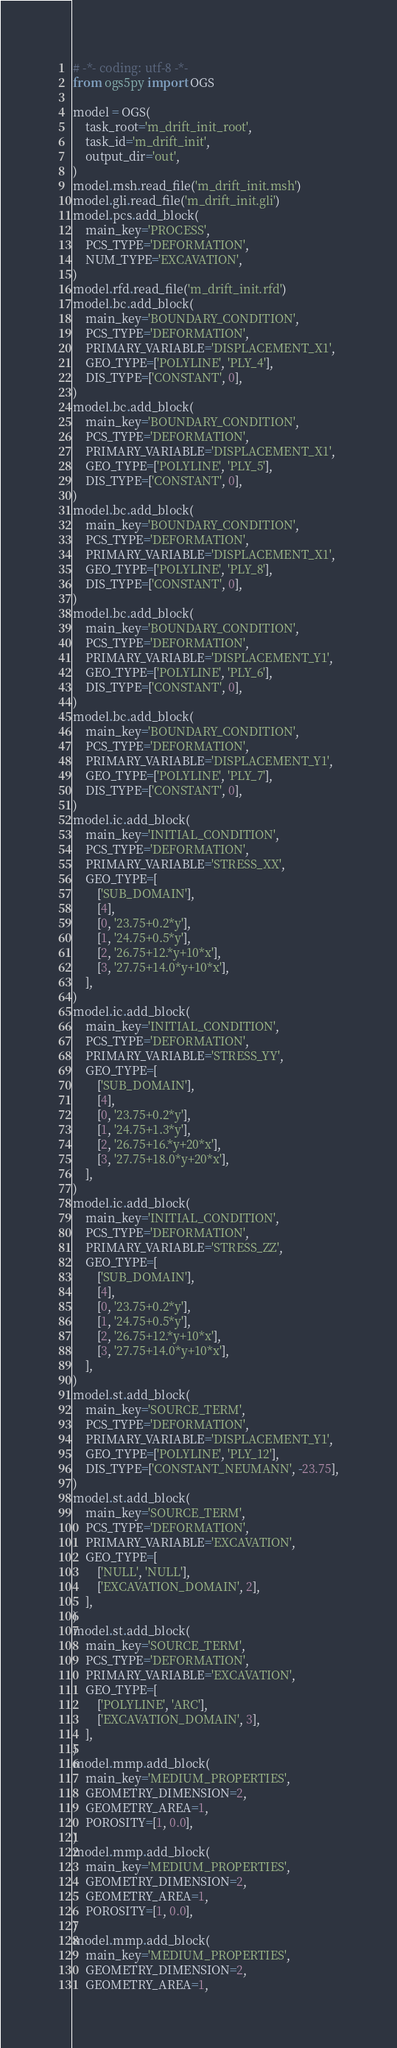<code> <loc_0><loc_0><loc_500><loc_500><_Python_># -*- coding: utf-8 -*-
from ogs5py import OGS

model = OGS(
    task_root='m_drift_init_root',
    task_id='m_drift_init',
    output_dir='out',
)
model.msh.read_file('m_drift_init.msh')
model.gli.read_file('m_drift_init.gli')
model.pcs.add_block(
    main_key='PROCESS',
    PCS_TYPE='DEFORMATION',
    NUM_TYPE='EXCAVATION',
)
model.rfd.read_file('m_drift_init.rfd')
model.bc.add_block(
    main_key='BOUNDARY_CONDITION',
    PCS_TYPE='DEFORMATION',
    PRIMARY_VARIABLE='DISPLACEMENT_X1',
    GEO_TYPE=['POLYLINE', 'PLY_4'],
    DIS_TYPE=['CONSTANT', 0],
)
model.bc.add_block(
    main_key='BOUNDARY_CONDITION',
    PCS_TYPE='DEFORMATION',
    PRIMARY_VARIABLE='DISPLACEMENT_X1',
    GEO_TYPE=['POLYLINE', 'PLY_5'],
    DIS_TYPE=['CONSTANT', 0],
)
model.bc.add_block(
    main_key='BOUNDARY_CONDITION',
    PCS_TYPE='DEFORMATION',
    PRIMARY_VARIABLE='DISPLACEMENT_X1',
    GEO_TYPE=['POLYLINE', 'PLY_8'],
    DIS_TYPE=['CONSTANT', 0],
)
model.bc.add_block(
    main_key='BOUNDARY_CONDITION',
    PCS_TYPE='DEFORMATION',
    PRIMARY_VARIABLE='DISPLACEMENT_Y1',
    GEO_TYPE=['POLYLINE', 'PLY_6'],
    DIS_TYPE=['CONSTANT', 0],
)
model.bc.add_block(
    main_key='BOUNDARY_CONDITION',
    PCS_TYPE='DEFORMATION',
    PRIMARY_VARIABLE='DISPLACEMENT_Y1',
    GEO_TYPE=['POLYLINE', 'PLY_7'],
    DIS_TYPE=['CONSTANT', 0],
)
model.ic.add_block(
    main_key='INITIAL_CONDITION',
    PCS_TYPE='DEFORMATION',
    PRIMARY_VARIABLE='STRESS_XX',
    GEO_TYPE=[
        ['SUB_DOMAIN'],
        [4],
        [0, '23.75+0.2*y'],
        [1, '24.75+0.5*y'],
        [2, '26.75+12.*y+10*x'],
        [3, '27.75+14.0*y+10*x'],
    ],
)
model.ic.add_block(
    main_key='INITIAL_CONDITION',
    PCS_TYPE='DEFORMATION',
    PRIMARY_VARIABLE='STRESS_YY',
    GEO_TYPE=[
        ['SUB_DOMAIN'],
        [4],
        [0, '23.75+0.2*y'],
        [1, '24.75+1.3*y'],
        [2, '26.75+16.*y+20*x'],
        [3, '27.75+18.0*y+20*x'],
    ],
)
model.ic.add_block(
    main_key='INITIAL_CONDITION',
    PCS_TYPE='DEFORMATION',
    PRIMARY_VARIABLE='STRESS_ZZ',
    GEO_TYPE=[
        ['SUB_DOMAIN'],
        [4],
        [0, '23.75+0.2*y'],
        [1, '24.75+0.5*y'],
        [2, '26.75+12.*y+10*x'],
        [3, '27.75+14.0*y+10*x'],
    ],
)
model.st.add_block(
    main_key='SOURCE_TERM',
    PCS_TYPE='DEFORMATION',
    PRIMARY_VARIABLE='DISPLACEMENT_Y1',
    GEO_TYPE=['POLYLINE', 'PLY_12'],
    DIS_TYPE=['CONSTANT_NEUMANN', -23.75],
)
model.st.add_block(
    main_key='SOURCE_TERM',
    PCS_TYPE='DEFORMATION',
    PRIMARY_VARIABLE='EXCAVATION',
    GEO_TYPE=[
        ['NULL', 'NULL'],
        ['EXCAVATION_DOMAIN', 2],
    ],
)
model.st.add_block(
    main_key='SOURCE_TERM',
    PCS_TYPE='DEFORMATION',
    PRIMARY_VARIABLE='EXCAVATION',
    GEO_TYPE=[
        ['POLYLINE', 'ARC'],
        ['EXCAVATION_DOMAIN', 3],
    ],
)
model.mmp.add_block(
    main_key='MEDIUM_PROPERTIES',
    GEOMETRY_DIMENSION=2,
    GEOMETRY_AREA=1,
    POROSITY=[1, 0.0],
)
model.mmp.add_block(
    main_key='MEDIUM_PROPERTIES',
    GEOMETRY_DIMENSION=2,
    GEOMETRY_AREA=1,
    POROSITY=[1, 0.0],
)
model.mmp.add_block(
    main_key='MEDIUM_PROPERTIES',
    GEOMETRY_DIMENSION=2,
    GEOMETRY_AREA=1,</code> 